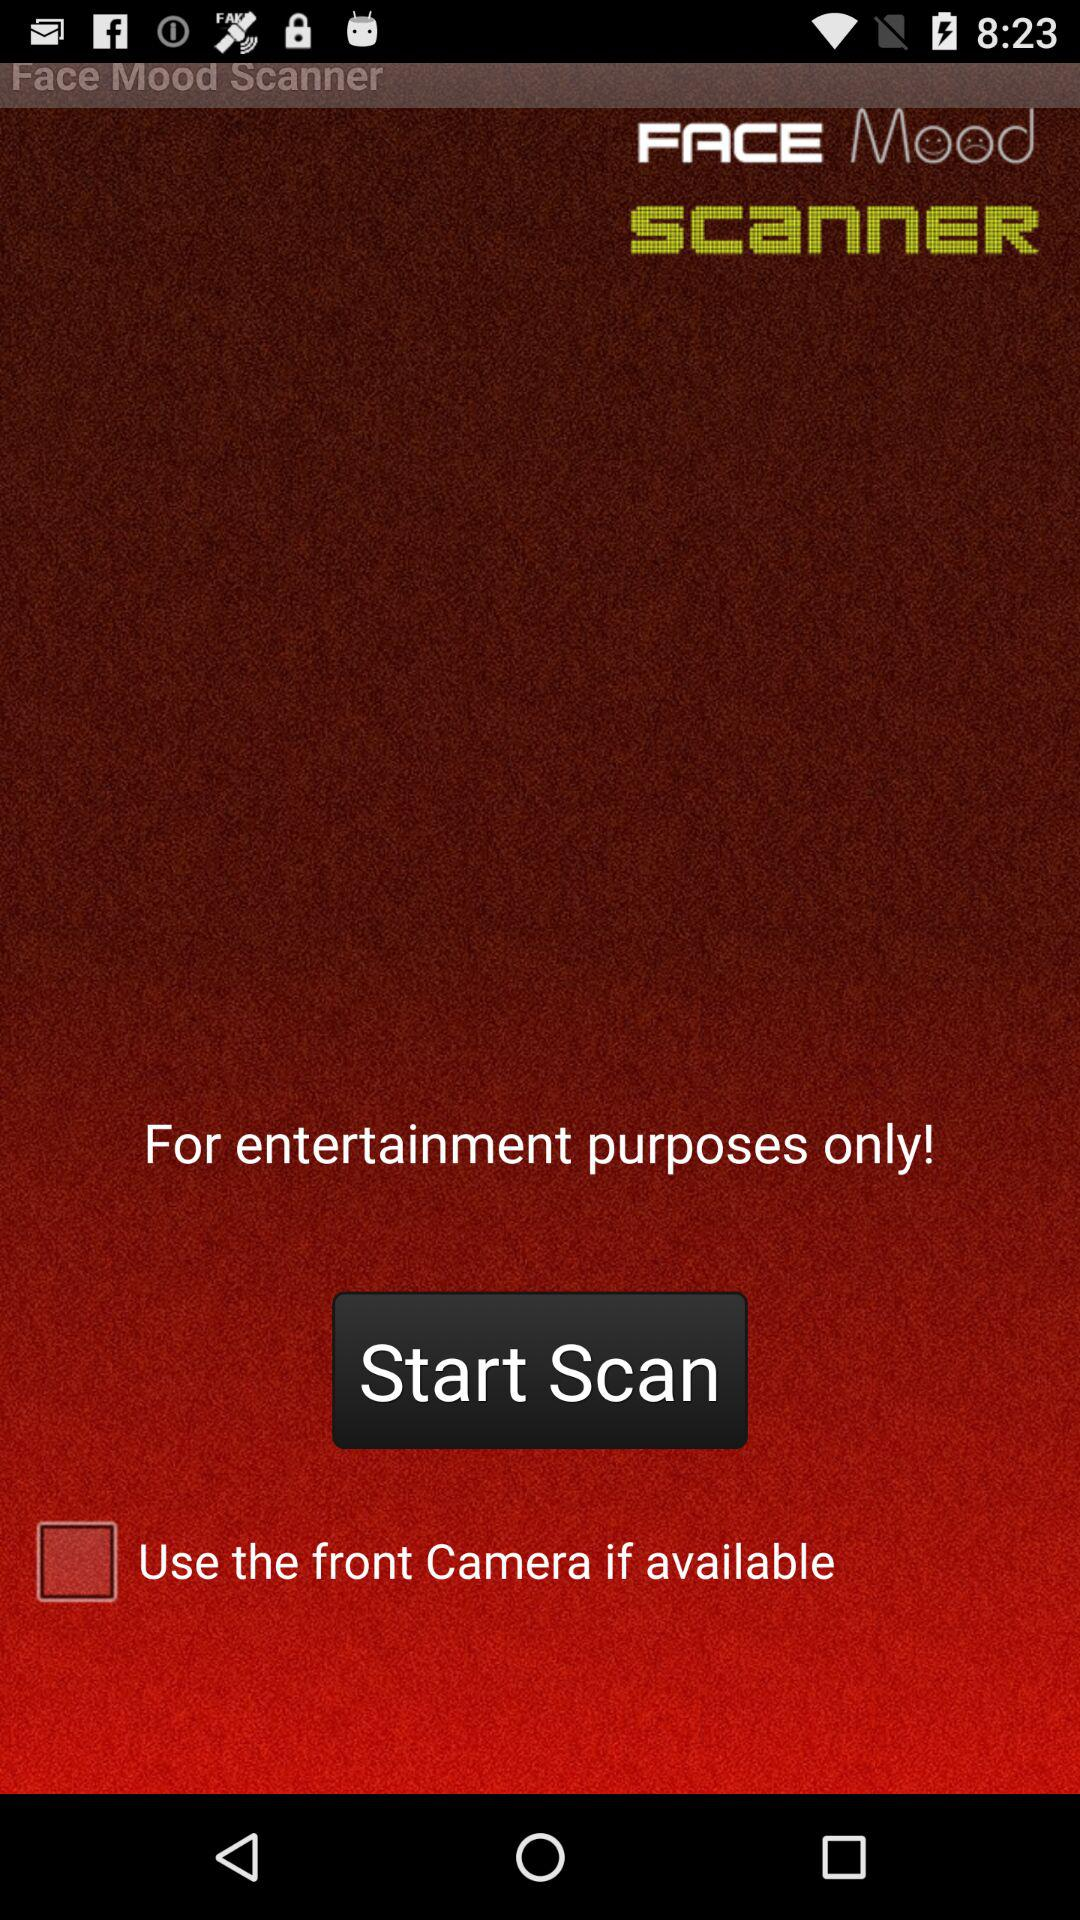What is the name of the application? The name of the application is Face Mood Scanner. 